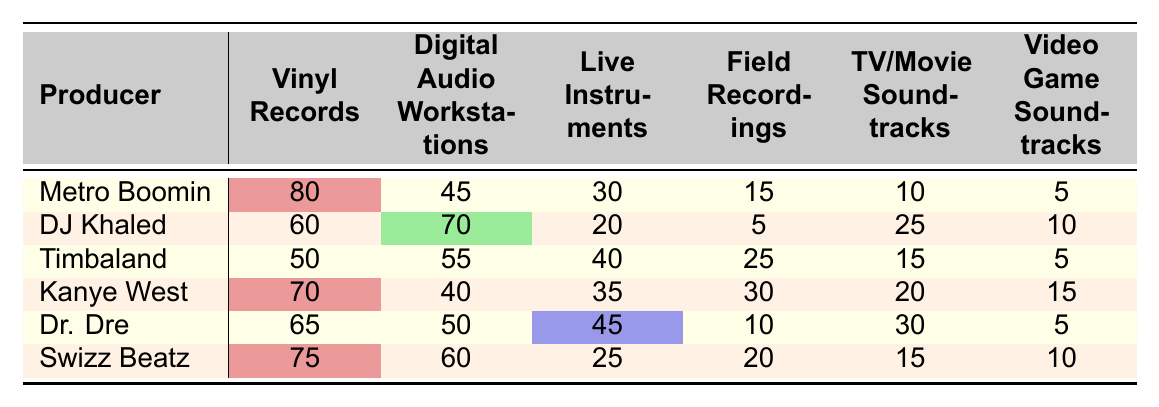What is the highest frequency of use for Vinyl Records among the producers? Looking through the table, Metro Boomin has the highest frequency at 80.
Answer: 80 Which producer uses Digital Audio Workstations the most? DJ Khaled shows the highest usage with a frequency of 70.
Answer: DJ Khaled What is the average frequency of use for Live Instruments across all producers? The frequencies for Live Instruments are 30, 20, 40, 35, 45, and 25. The sum is 195, and the average is 195 divided by 6, which equals 32.5.
Answer: 32.5 Is it true that Dr. Dre uses Video Game Soundtracks more than 10? Dr. Dre has a frequency of 5 for Video Game Soundtracks, which is less than 10.
Answer: No Which sample source has the lowest frequency of use by Timbaland? The lowest frequency for Timbaland is for Video Game Soundtracks, which is 5.
Answer: 5 What is the total frequency of use for TV/Movie Soundtracks across all producers? Adding each producer's frequency: 10 (Metro Boomin) + 25 (DJ Khaled) + 15 (Timbaland) + 20 (Kanye West) + 30 (Dr. Dre) + 15 (Swizz Beatz) equals 115.
Answer: 115 Which producer has the second highest usage of Field Recordings? Analyzing the frequencies for Field Recordings, Kanye West has 30, which is the second highest after Timbaland with 25.
Answer: Kanye West If we look at the total frequency of Vinyl Records and Digital Audio Workstations, which producer has the highest combined total? Adding the frequencies for both sources: Metro Boomin (80 + 45 = 125), DJ Khaled (60 + 70 = 130), and so on. The highest combined total is DJ Khaled with 130.
Answer: DJ Khaled How many producers use Live Instruments more than 35 times? The producers that use Live Instruments more than 35 times are Timbaland (40), Kanye West (35), and Dr. Dre (45). This makes 3 producers in total.
Answer: 3 Which two sample sources have the highest frequencies for Swizz Beatz? Swizz Beatz has the highest frequencies in Vinyl Records (75) and Digital Audio Workstations (60).
Answer: Vinyl Records and Digital Audio Workstations 